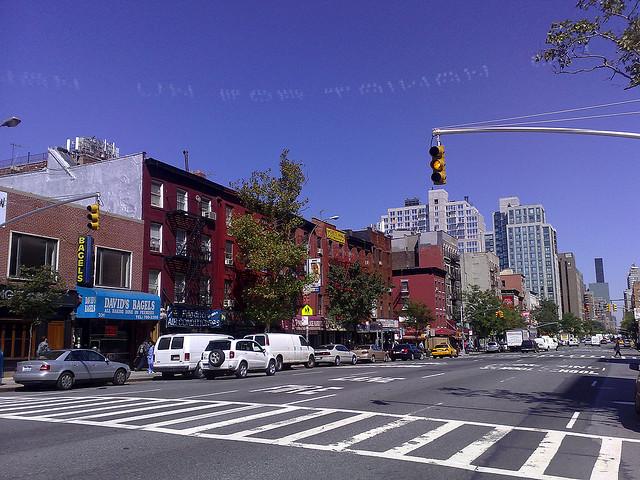At what time did the traffic change from green to yellow?
Answer briefly. Unknown. How many stripes are painted on the crosswalk?
Short answer required. 15. Which color is the traffic signal currently showing?
Give a very brief answer. Yellow. 